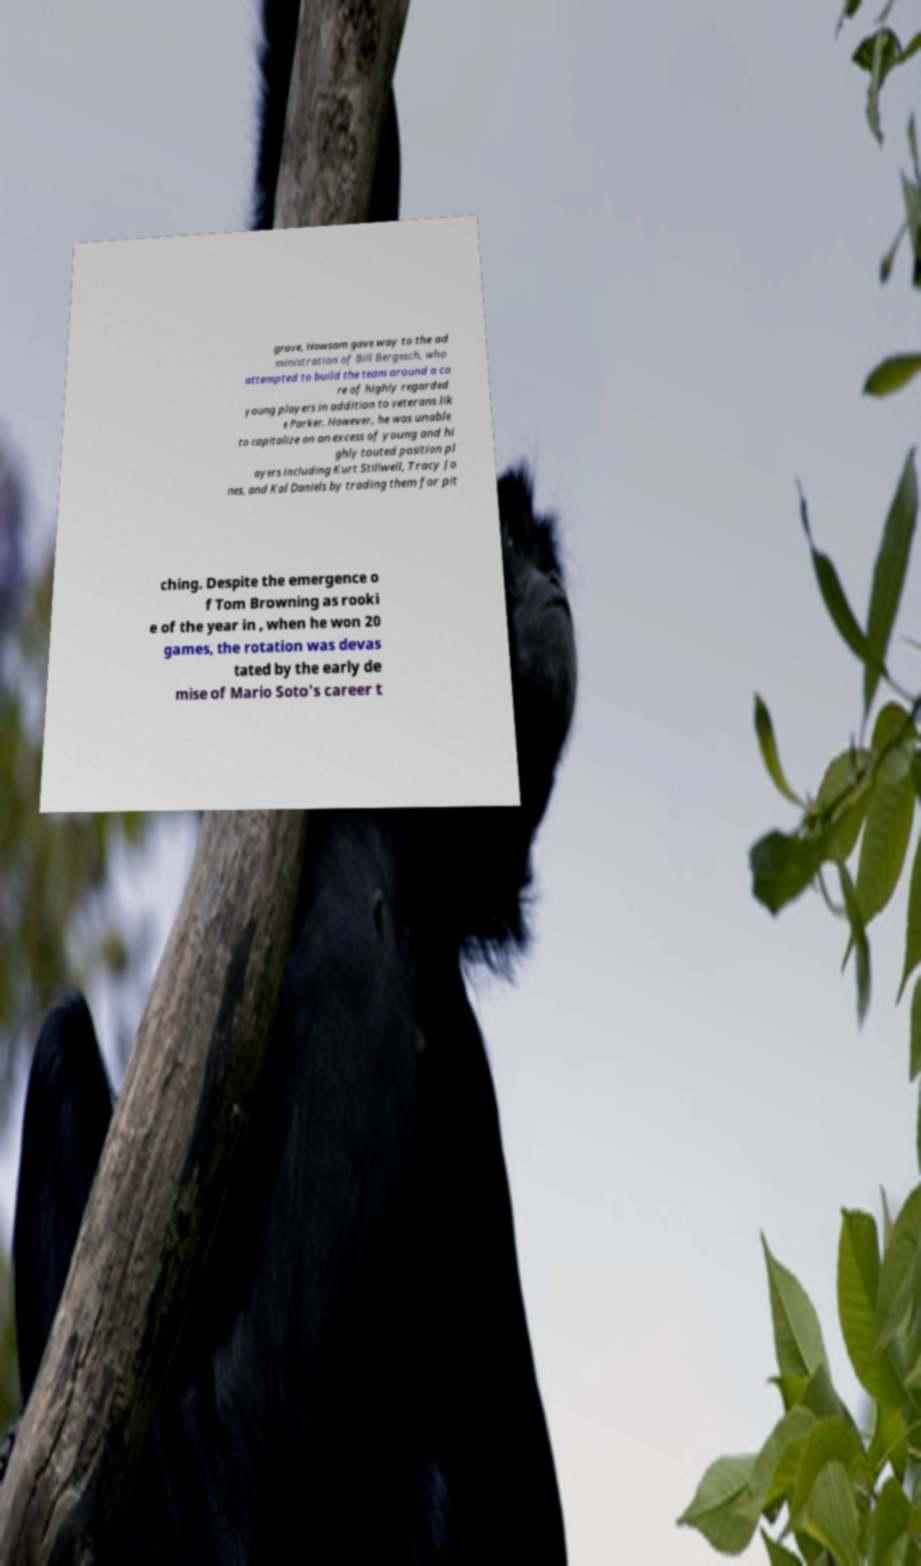What messages or text are displayed in this image? I need them in a readable, typed format. grave, Howsam gave way to the ad ministration of Bill Bergesch, who attempted to build the team around a co re of highly regarded young players in addition to veterans lik e Parker. However, he was unable to capitalize on an excess of young and hi ghly touted position pl ayers including Kurt Stillwell, Tracy Jo nes, and Kal Daniels by trading them for pit ching. Despite the emergence o f Tom Browning as rooki e of the year in , when he won 20 games, the rotation was devas tated by the early de mise of Mario Soto's career t 